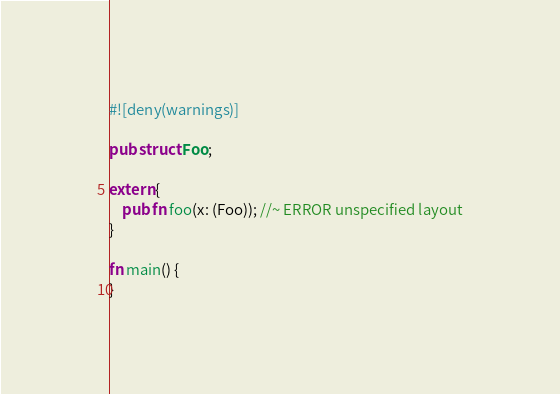Convert code to text. <code><loc_0><loc_0><loc_500><loc_500><_Rust_>#![deny(warnings)]

pub struct Foo;

extern {
    pub fn foo(x: (Foo)); //~ ERROR unspecified layout
}

fn main() {
}
</code> 